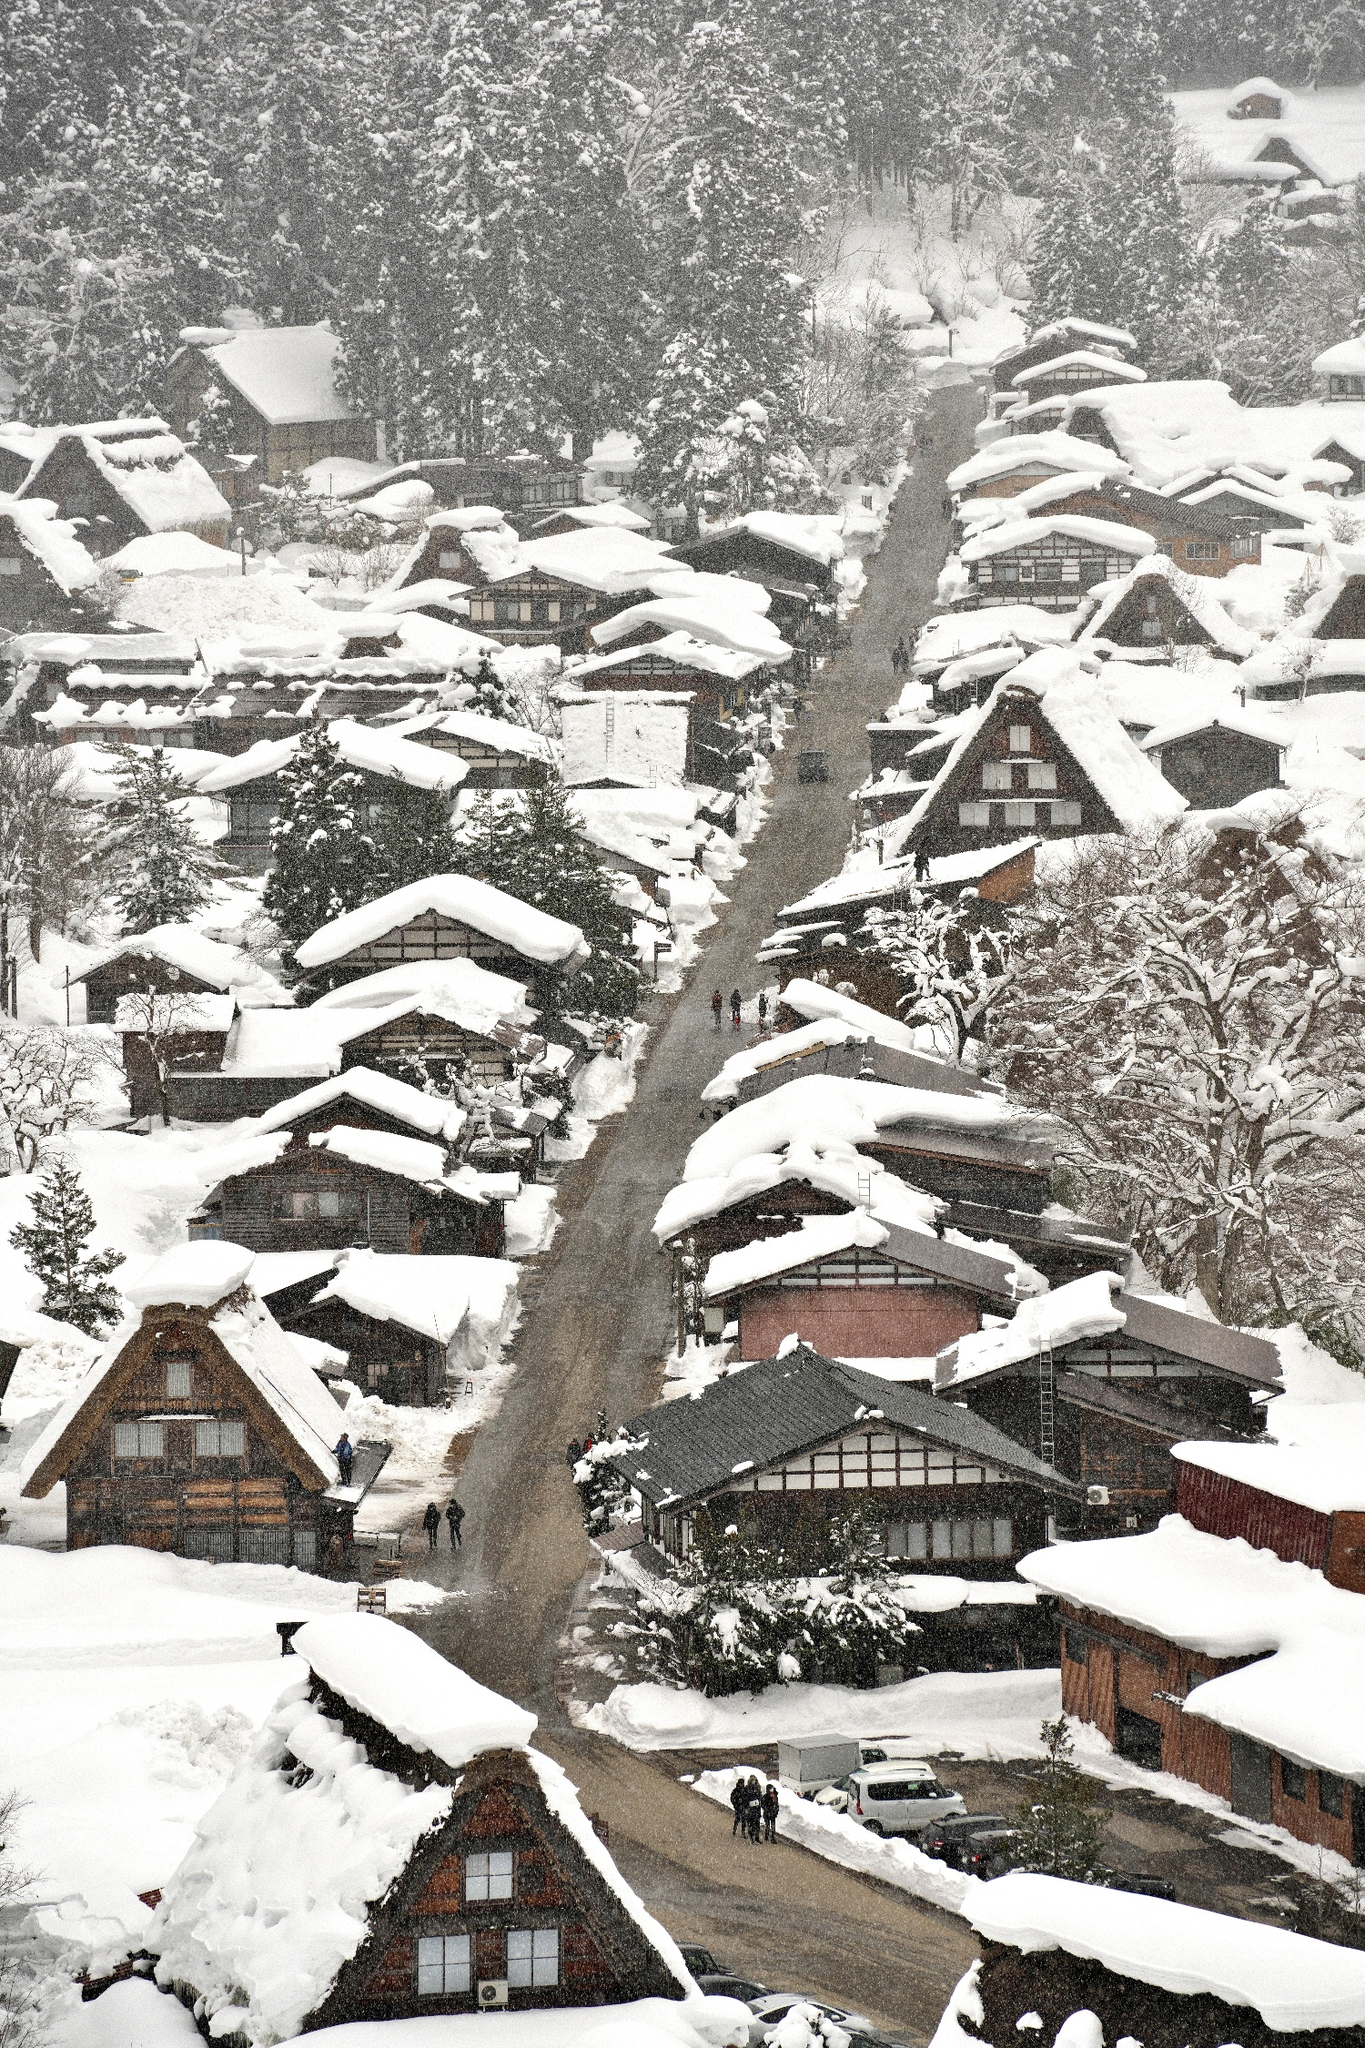What is this photo about'?
 The image captures the serene beauty of the historic village of Shirakawa-go in Japan, a UNESCO World Heritage Site. The village is nestled in a valley and viewed from a high vantage point, providing a panoramic view of the entire area. The traditional gassho-zukuri farmhouses, characterized by their steeply slanting thatched roofs, are scattered across the landscape. These roofs are almost entirely blanketed by a thick layer of snow, reflecting the harsh winter conditions. The day is overcast, with a grey sky looming above, casting a soft light over the scene. The predominant colors in the image are the stark white of the snow and the muted grey of the sky, punctuated by the dark brown and black accents of the farmhouses and the bare trees. The perspective of the image, taken from above, adds a sense of depth and scale, emphasizing the isolation and tranquility of the village amidst the vast, snow-covered landscape. 